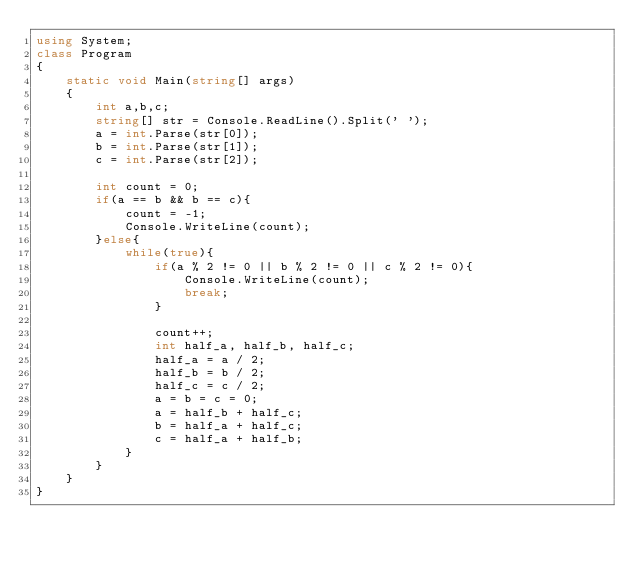<code> <loc_0><loc_0><loc_500><loc_500><_C#_>using System;
class Program
{
    static void Main(string[] args)
    {
        int a,b,c;
        string[] str = Console.ReadLine().Split(' ');
        a = int.Parse(str[0]);
        b = int.Parse(str[1]);
        c = int.Parse(str[2]);
        
        int count = 0;
        if(a == b && b == c){
            count = -1;
            Console.WriteLine(count);
        }else{
            while(true){
                if(a % 2 != 0 || b % 2 != 0 || c % 2 != 0){
                    Console.WriteLine(count);
                    break;
                }

                count++;
                int half_a, half_b, half_c;
                half_a = a / 2;
                half_b = b / 2;
                half_c = c / 2;
                a = b = c = 0;
                a = half_b + half_c;
                b = half_a + half_c;
                c = half_a + half_b;
            }
        }
    }
}</code> 